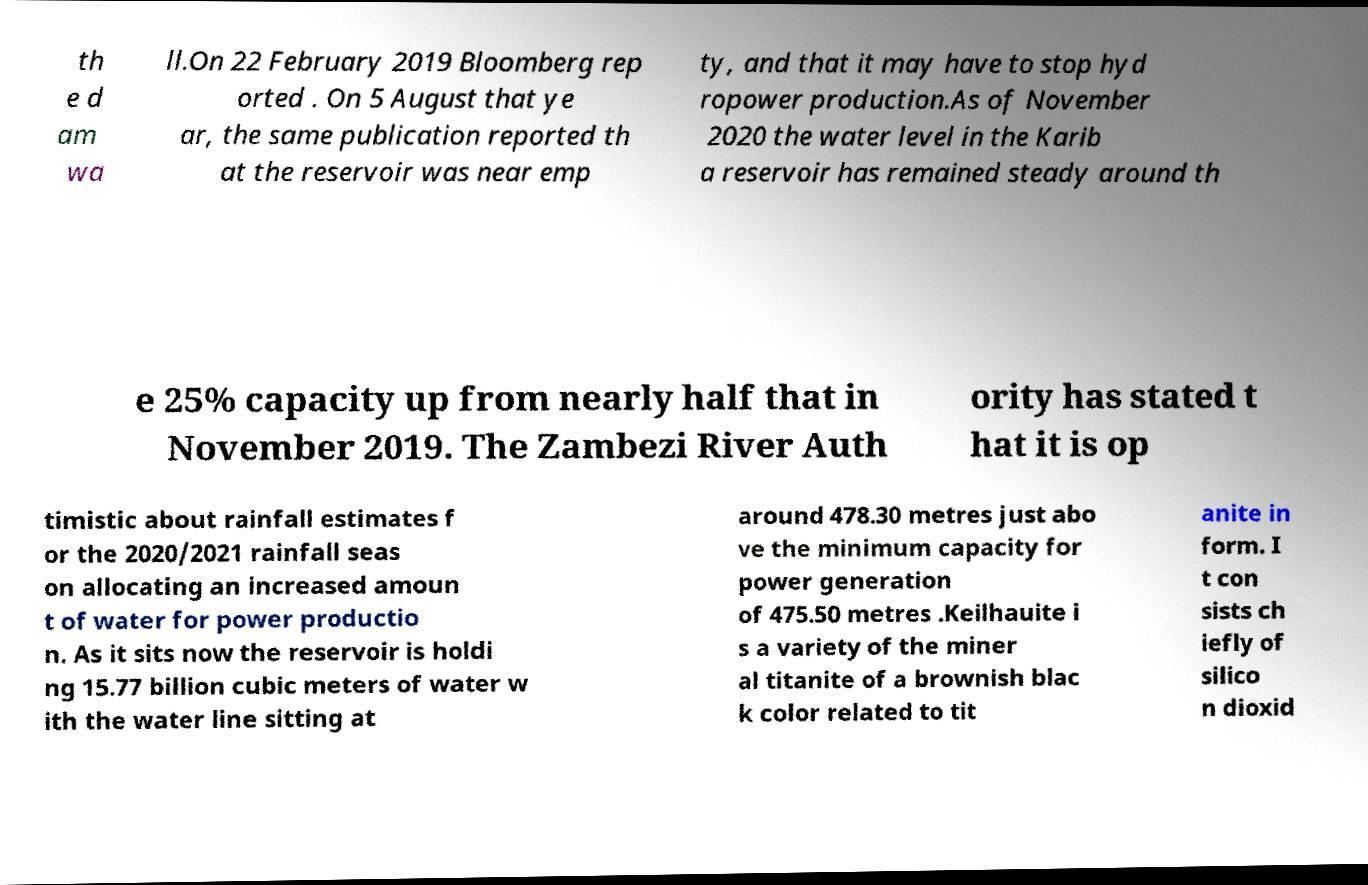Please read and relay the text visible in this image. What does it say? th e d am wa ll.On 22 February 2019 Bloomberg rep orted . On 5 August that ye ar, the same publication reported th at the reservoir was near emp ty, and that it may have to stop hyd ropower production.As of November 2020 the water level in the Karib a reservoir has remained steady around th e 25% capacity up from nearly half that in November 2019. The Zambezi River Auth ority has stated t hat it is op timistic about rainfall estimates f or the 2020/2021 rainfall seas on allocating an increased amoun t of water for power productio n. As it sits now the reservoir is holdi ng 15.77 billion cubic meters of water w ith the water line sitting at around 478.30 metres just abo ve the minimum capacity for power generation of 475.50 metres .Keilhauite i s a variety of the miner al titanite of a brownish blac k color related to tit anite in form. I t con sists ch iefly of silico n dioxid 